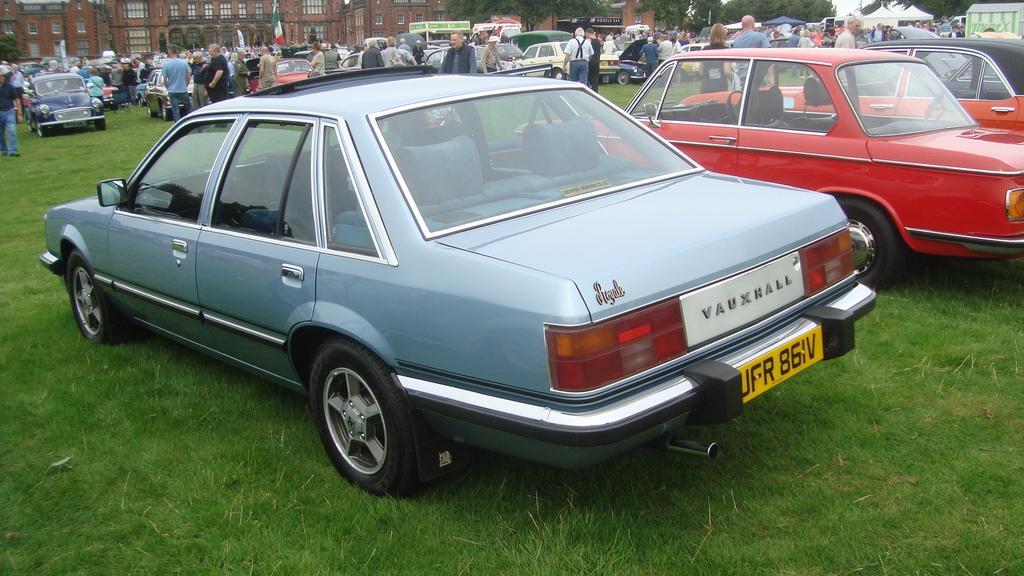How would you summarize this image in a sentence or two? In this image there are buildings truncated towards the top of the image, there are trees truncated towards the top of the image, there are cars, there are cars truncated towards the right of the image, there is an object truncated towards the right of the image, there are group of persons, there are person truncated towards the left of the image, there is a tree truncated towards the left of the image, there is a flag, there is the grass, there are tents. 